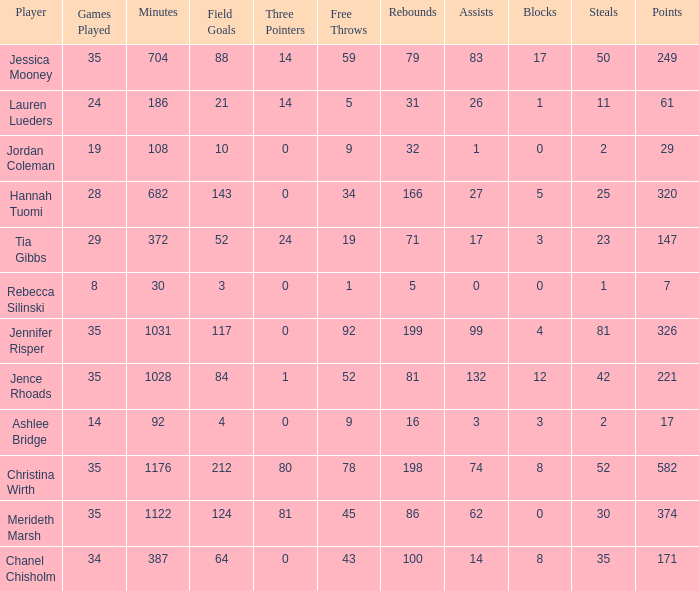What is the lowest number of games played by the player with 50 steals? 35.0. 